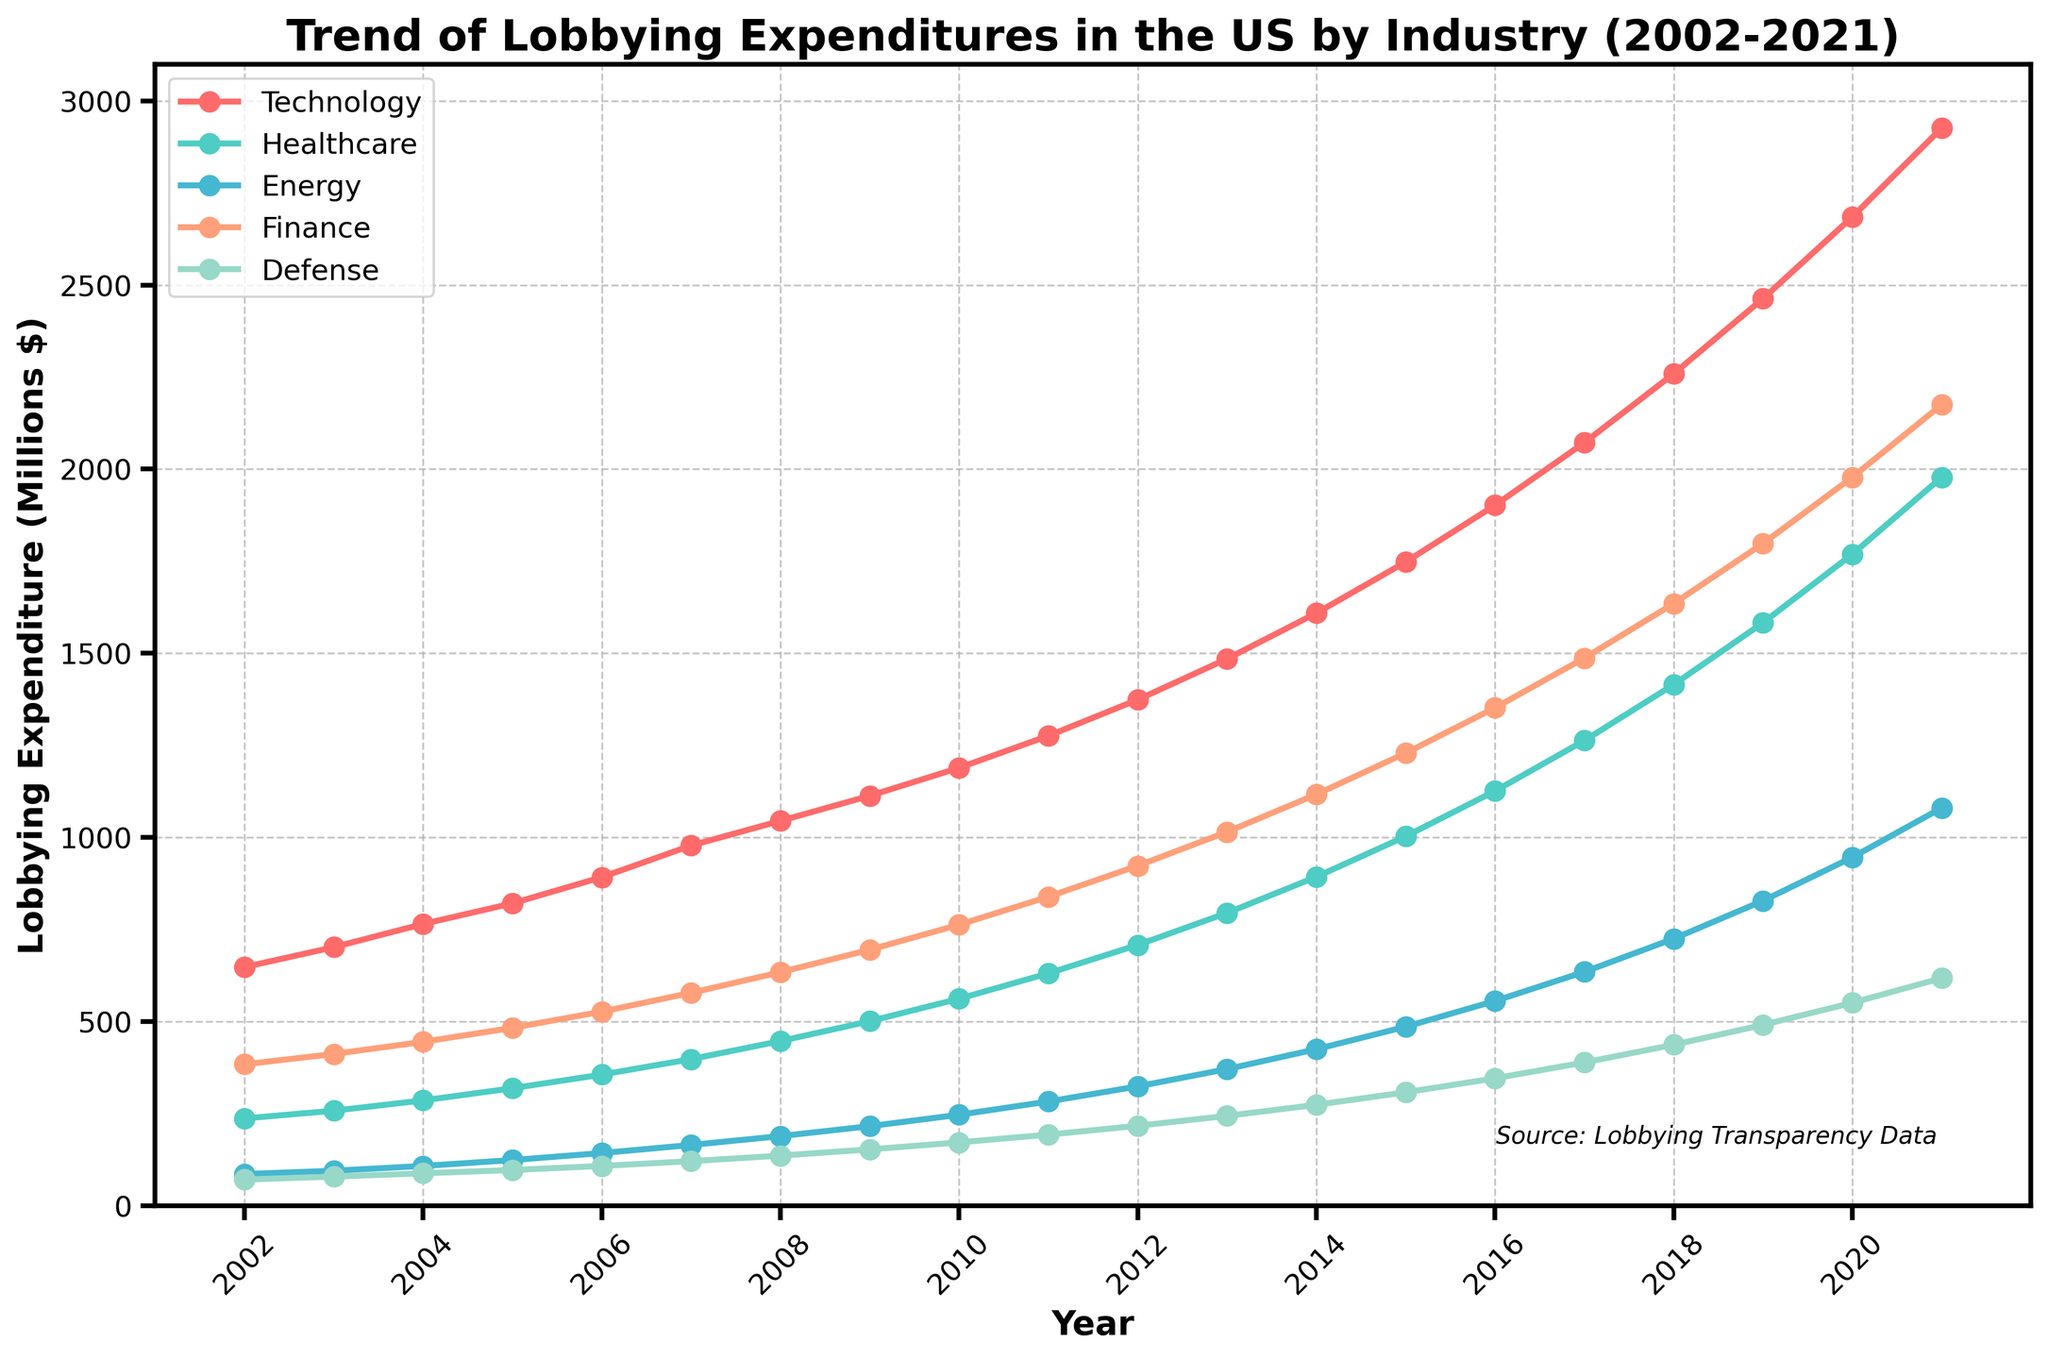What industry saw the highest increase in lobbying expenditures from 2002 to 2021? Look at the final points in 2021 for each industry and determine which has the largest difference from its starting point in 2002. Technology starts at 648 and ends at 2926, an increase of 2278, which is the highest among all industries.
Answer: Technology Which two industries had almost equal lobbying expenditures in 2013? By observing the lines around the year 2013 on the plot, Healthcare and Defense have quite close values. Healthcare is at 795 and Defense is at 274. However, compared to Finance which is 1015, the closer pair is Healthcare and Finance.
Answer: Healthcare and Finance What is the average lobbying expenditure of the Healthcare industry between 2002 and 2021? Sum the lobbying expenditures for Healthcare for each year from 2002 to 2021 and divide by the number of years (20). (237 + 258 + 286 + 319 + 356 + 398 + 447 + 501 + 562 + 631 + 708 + 795 + 893 + 1003 + 1126 + 1263 + 1415 + 1583 + 1769 + 1978) = 20428 / 20 = 1021.4
Answer: 1021.4 Which industry had the smallest increase in lobbying expenditures from 2002 to 2021? Calculate the increase for each industry. Technology: 2278, Healthcare: 1741, Energy: 994, Finance: 1791, Defense: 547. Defense had the smallest increase.
Answer: Defense Between which years did the Technology industry see the largest yearly increase in lobbying expenditures? Analyze the year-to-year changes by subtracting each year’s expenditure from the next year’s. The largest increase for Technology is between 2020 (2685) and 2021 (2926), which is a 241 million increase.
Answer: 2020-2021 In what year did Finance lobbying expenditures surpass 1000 million dollars? Follow the Finance line and identify the point where the value exceeds 1000 million. In 2013, Finance reaches 1015.
Answer: 2013 Compare the lobbying expenditures growth of Technology and Energy from 2002 to 2021. Determine the total growth for each, Technology: 2278 (2926-648), and Energy: 994 (1080-86). Technology grew more than Energy over these years.
Answer: Technology grew more What are the total lobbying expenditures for Healthcare and Finance together in 2010? Add the expenditures for Healthcare (562) and Finance (763) together for 2010. 562 + 763 = 1325.
Answer: 1325 Which industry experienced almost linear growth in lobbying expenditures over the 20 years? By visually examining the trends, Healthcare exhibits a fairly steady linear increase without sharp variations year to year.
Answer: Healthcare In what year did Defense lobbying expenditures first surpass 200 million dollars? Track the Defense line to see where it exceeds 200 million, which occurs in 2021 with a value of 618.
Answer: 2021 